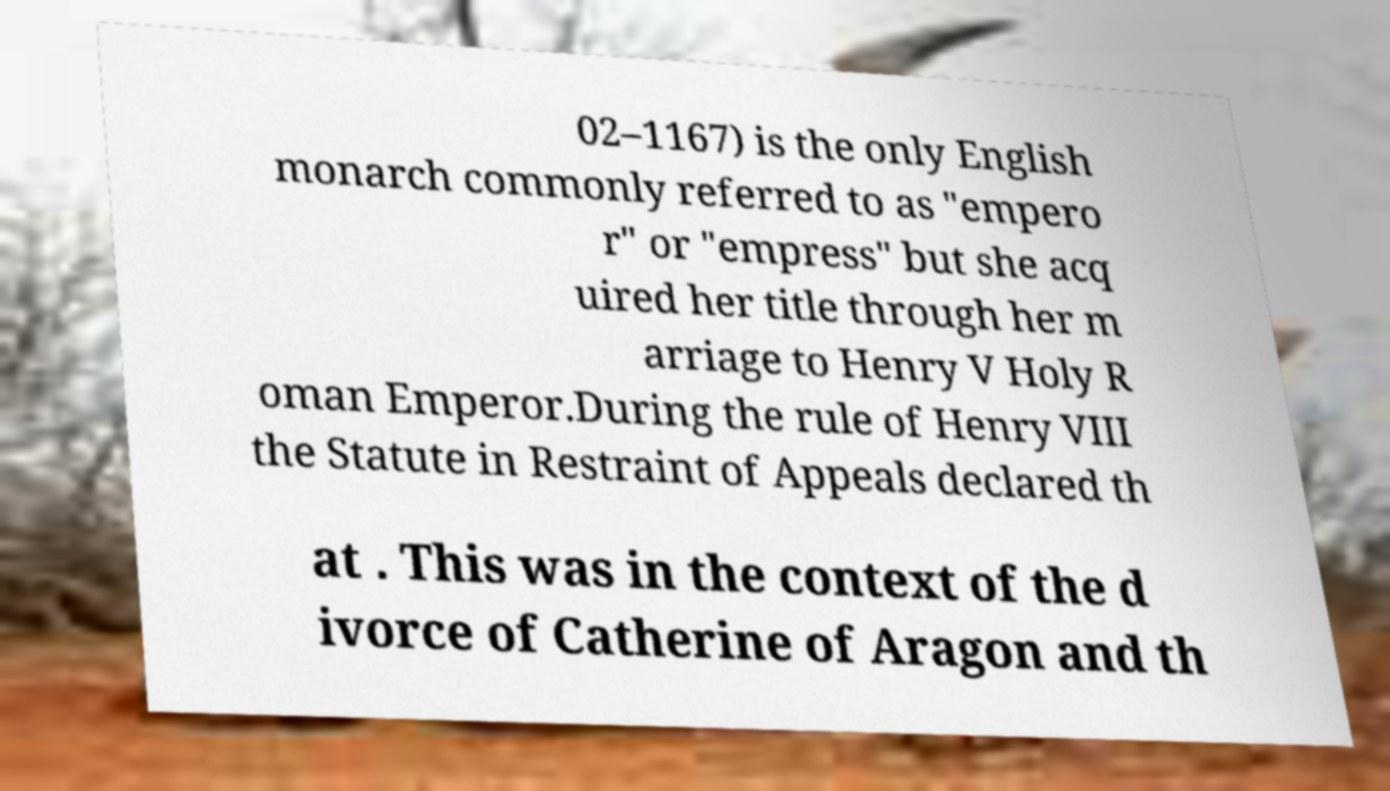Could you assist in decoding the text presented in this image and type it out clearly? 02–1167) is the only English monarch commonly referred to as "empero r" or "empress" but she acq uired her title through her m arriage to Henry V Holy R oman Emperor.During the rule of Henry VIII the Statute in Restraint of Appeals declared th at . This was in the context of the d ivorce of Catherine of Aragon and th 